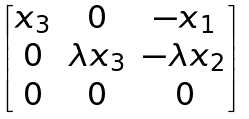Convert formula to latex. <formula><loc_0><loc_0><loc_500><loc_500>\begin{bmatrix} x _ { 3 } & 0 & - x _ { 1 } \\ 0 & \lambda x _ { 3 } & - \lambda x _ { 2 } \\ 0 & 0 & 0 \end{bmatrix}</formula> 